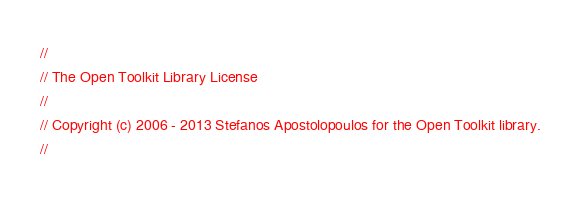<code> <loc_0><loc_0><loc_500><loc_500><_C#_>//
// The Open Toolkit Library License
//
// Copyright (c) 2006 - 2013 Stefanos Apostolopoulos for the Open Toolkit library.
//</code> 